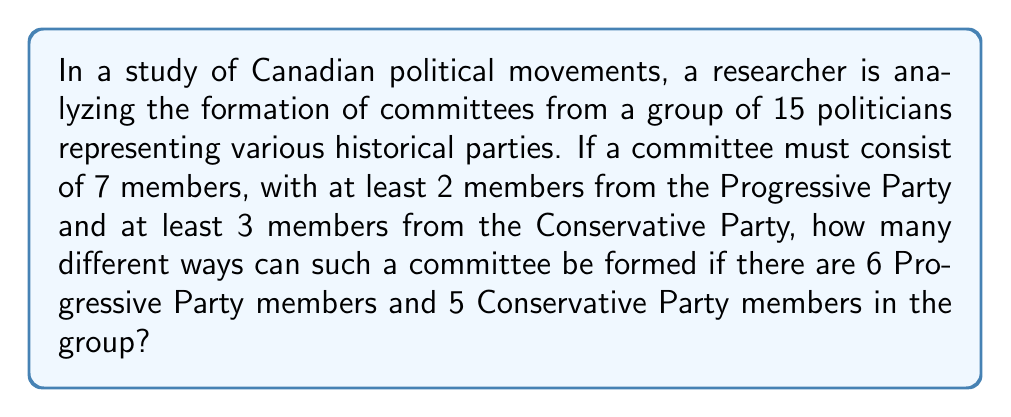Provide a solution to this math problem. Let's approach this step-by-step:

1) First, we need to choose the Progressive Party members:
   - We must choose at least 2, but we can't choose more than 4 (because we need to leave room for at least 3 Conservatives).
   - So we can choose 2, 3, or 4 Progressive members.

2) For each of these cases, we then need to choose the Conservative Party members:
   - We must choose at least 3, and the total committee size must be 7.

3) Let's break it down:

   Case 1: 2 Progressives
   - Choose 2 from 6 Progressives: $\binom{6}{2}$
   - We need 5 more, so choose 5 from 5 Conservatives: $\binom{5}{5}$

   Case 2: 3 Progressives
   - Choose 3 from 6 Progressives: $\binom{6}{3}$
   - We need 4 more, so choose 4 from 5 Conservatives: $\binom{5}{4}$

   Case 3: 4 Progressives
   - Choose 4 from 6 Progressives: $\binom{6}{4}$
   - We need 3 more, so choose 3 from 5 Conservatives: $\binom{5}{3}$

4) The total number of ways is the sum of these cases:

   $$\binom{6}{2}\binom{5}{5} + \binom{6}{3}\binom{5}{4} + \binom{6}{4}\binom{5}{3}$$

5) Let's calculate:
   $$15 \cdot 1 + 20 \cdot 5 + 15 \cdot 10 = 15 + 100 + 150 = 265$$

Therefore, there are 265 different ways to form such a committee.
Answer: 265 